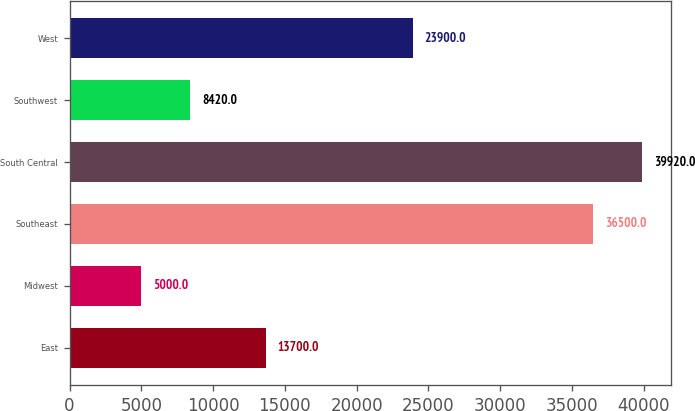Convert chart. <chart><loc_0><loc_0><loc_500><loc_500><bar_chart><fcel>East<fcel>Midwest<fcel>Southeast<fcel>South Central<fcel>Southwest<fcel>West<nl><fcel>13700<fcel>5000<fcel>36500<fcel>39920<fcel>8420<fcel>23900<nl></chart> 